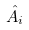<formula> <loc_0><loc_0><loc_500><loc_500>\hat { A } _ { i }</formula> 